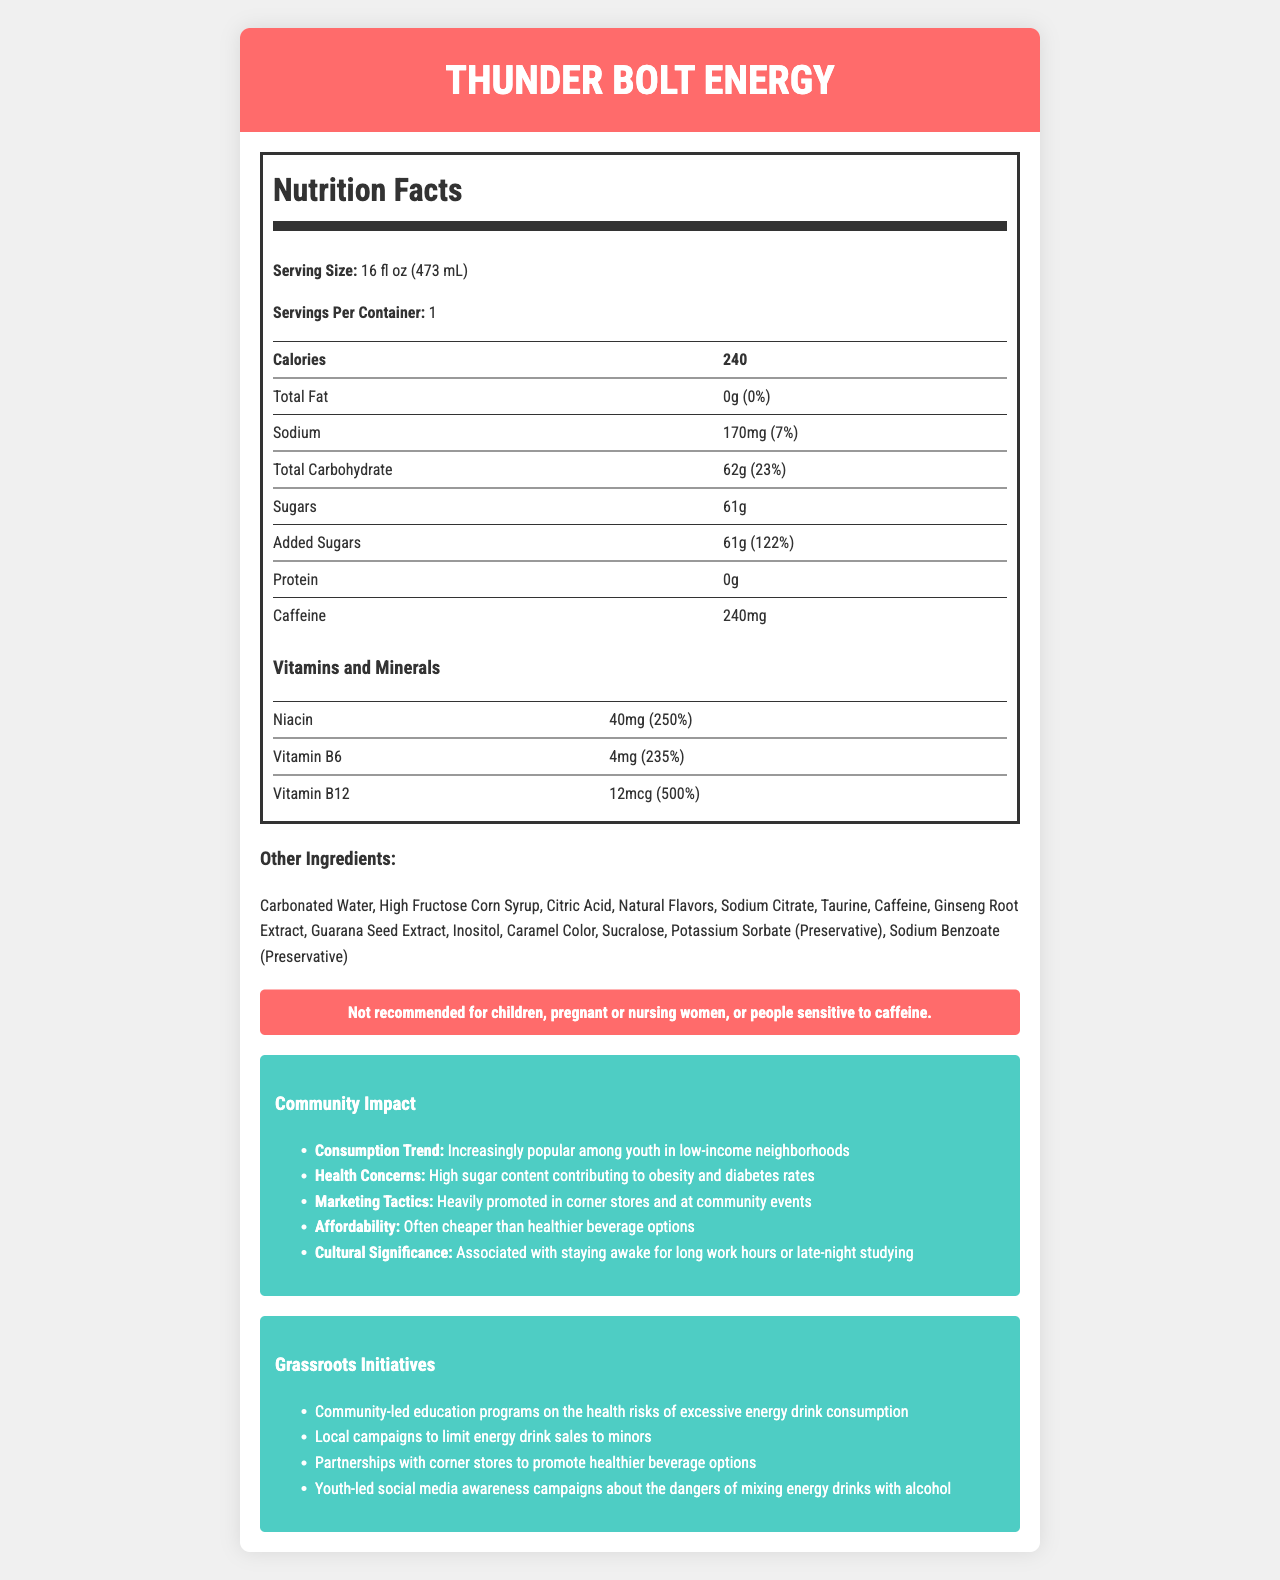what is the serving size for Thunder Bolt Energy? The serving size is listed at the top of the Nutrition Facts label.
Answer: 16 fl oz (473 mL) how many Calories are there per serving? The number of calories per serving is clearly mentioned in the Nutrition Facts label.
Answer: 240 what is the total carbohydrate amount per serving? The total carbohydrate amount is mentioned in the Nutrition Facts label.
Answer: 62g how much sodium is in one serving of Thunder Bolt Energy? The sodium content per serving is listed in the Nutrition Facts label.
Answer: 170mg how many grams of protein are found in Thunder Bolt Energy? The protein content per serving is shown as 0g in the Nutrition Facts label.
Answer: 0g which vitamin has the highest daily value percentage in Thunder Bolt Energy? A. Niacin B. Vitamin B6 C. Vitamin B12 The daily value percentage for Vitamin B12 is 500%, which is higher than Niacin (250%) and Vitamin B6 (235%).
Answer: C. Vitamin B12 of the following, which is NOT an ingredient in Thunder Bolt Energy? A. Taurine B. High Fructose Corn Syrup C. Ascorbic Acid Taurine and High Fructose Corn Syrup are listed in the ingredients, but Ascorbic Acid is not.
Answer: C. Ascorbic Acid is Thunder Bolt Energy recommended for children? The warning on the label states that it is not recommended for children.
Answer: No summarize the key information presented in the document. The key information includes nutritional content, community impact, health risks, and grassroots initiatives.
Answer: Thunder Bolt Energy is an energy drink with high sugar and caffeine content, providing significant amounts of Niacin, Vitamin B6, and Vitamin B12. It is increasingly popular among youth in low-income neighborhoods but raises health concerns such as obesity and diabetes. The document also highlights community impact and grassroots initiatives aimed at mitigating these effects. what is the main health concern associated with Thunder Bolt Energy's consumption trend? The community impact section mentions the health concern related to high sugar content leading to obesity and diabetes.
Answer: High sugar content contributing to obesity and diabetes rates can you determine the exact age restriction for purchasing Thunder Bolt Energy from the document? The document mentions it's not recommended for children but does not specify an exact age restriction for purchasing the product.
Answer: Not enough information how many mg of caffeine does Thunder Bolt Energy contain per serving? The amount of caffeine per serving is listed as 240mg in the Nutrition Facts label.
Answer: 240mg what dietary mineral is found in the highest quantity in Thunder Bolt Energy? The document indicates 170mg of sodium, the only dietary mineral listed, in Thunder Bolt Energy.
Answer: Sodium name one grassroots initiative aimed at reducing energy drink consumption in low-income neighborhoods. One of the initiatives mentioned is community-led education programs to inform about the health risks of excessive energy drink consumption.
Answer: Community-led education programs on the health risks of excessive energy drink consumption what percentage of Daily Value (%DV) does the amount of added sugars in Thunder Bolt Energy represent? The added sugars amount is 61g, which equals 122% of the Daily Value.
Answer: 122% 